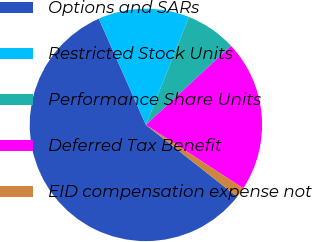Convert chart. <chart><loc_0><loc_0><loc_500><loc_500><pie_chart><fcel>Options and SARs<fcel>Restricted Stock Units<fcel>Performance Share Units<fcel>Deferred Tax Benefit<fcel>EID compensation expense not<nl><fcel>57.75%<fcel>12.68%<fcel>7.04%<fcel>21.13%<fcel>1.41%<nl></chart> 